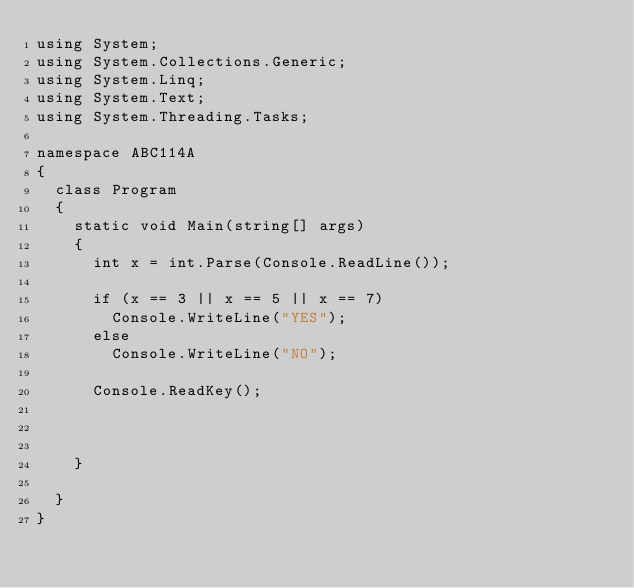Convert code to text. <code><loc_0><loc_0><loc_500><loc_500><_C#_>using System;
using System.Collections.Generic;
using System.Linq;
using System.Text;
using System.Threading.Tasks;

namespace ABC114A
{
	class Program
	{
		static void Main(string[] args)
		{
			int x = int.Parse(Console.ReadLine());

			if (x == 3 || x == 5 || x == 7)
				Console.WriteLine("YES");
			else
				Console.WriteLine("NO");

			Console.ReadKey();


		  
		}

	}
}
</code> 